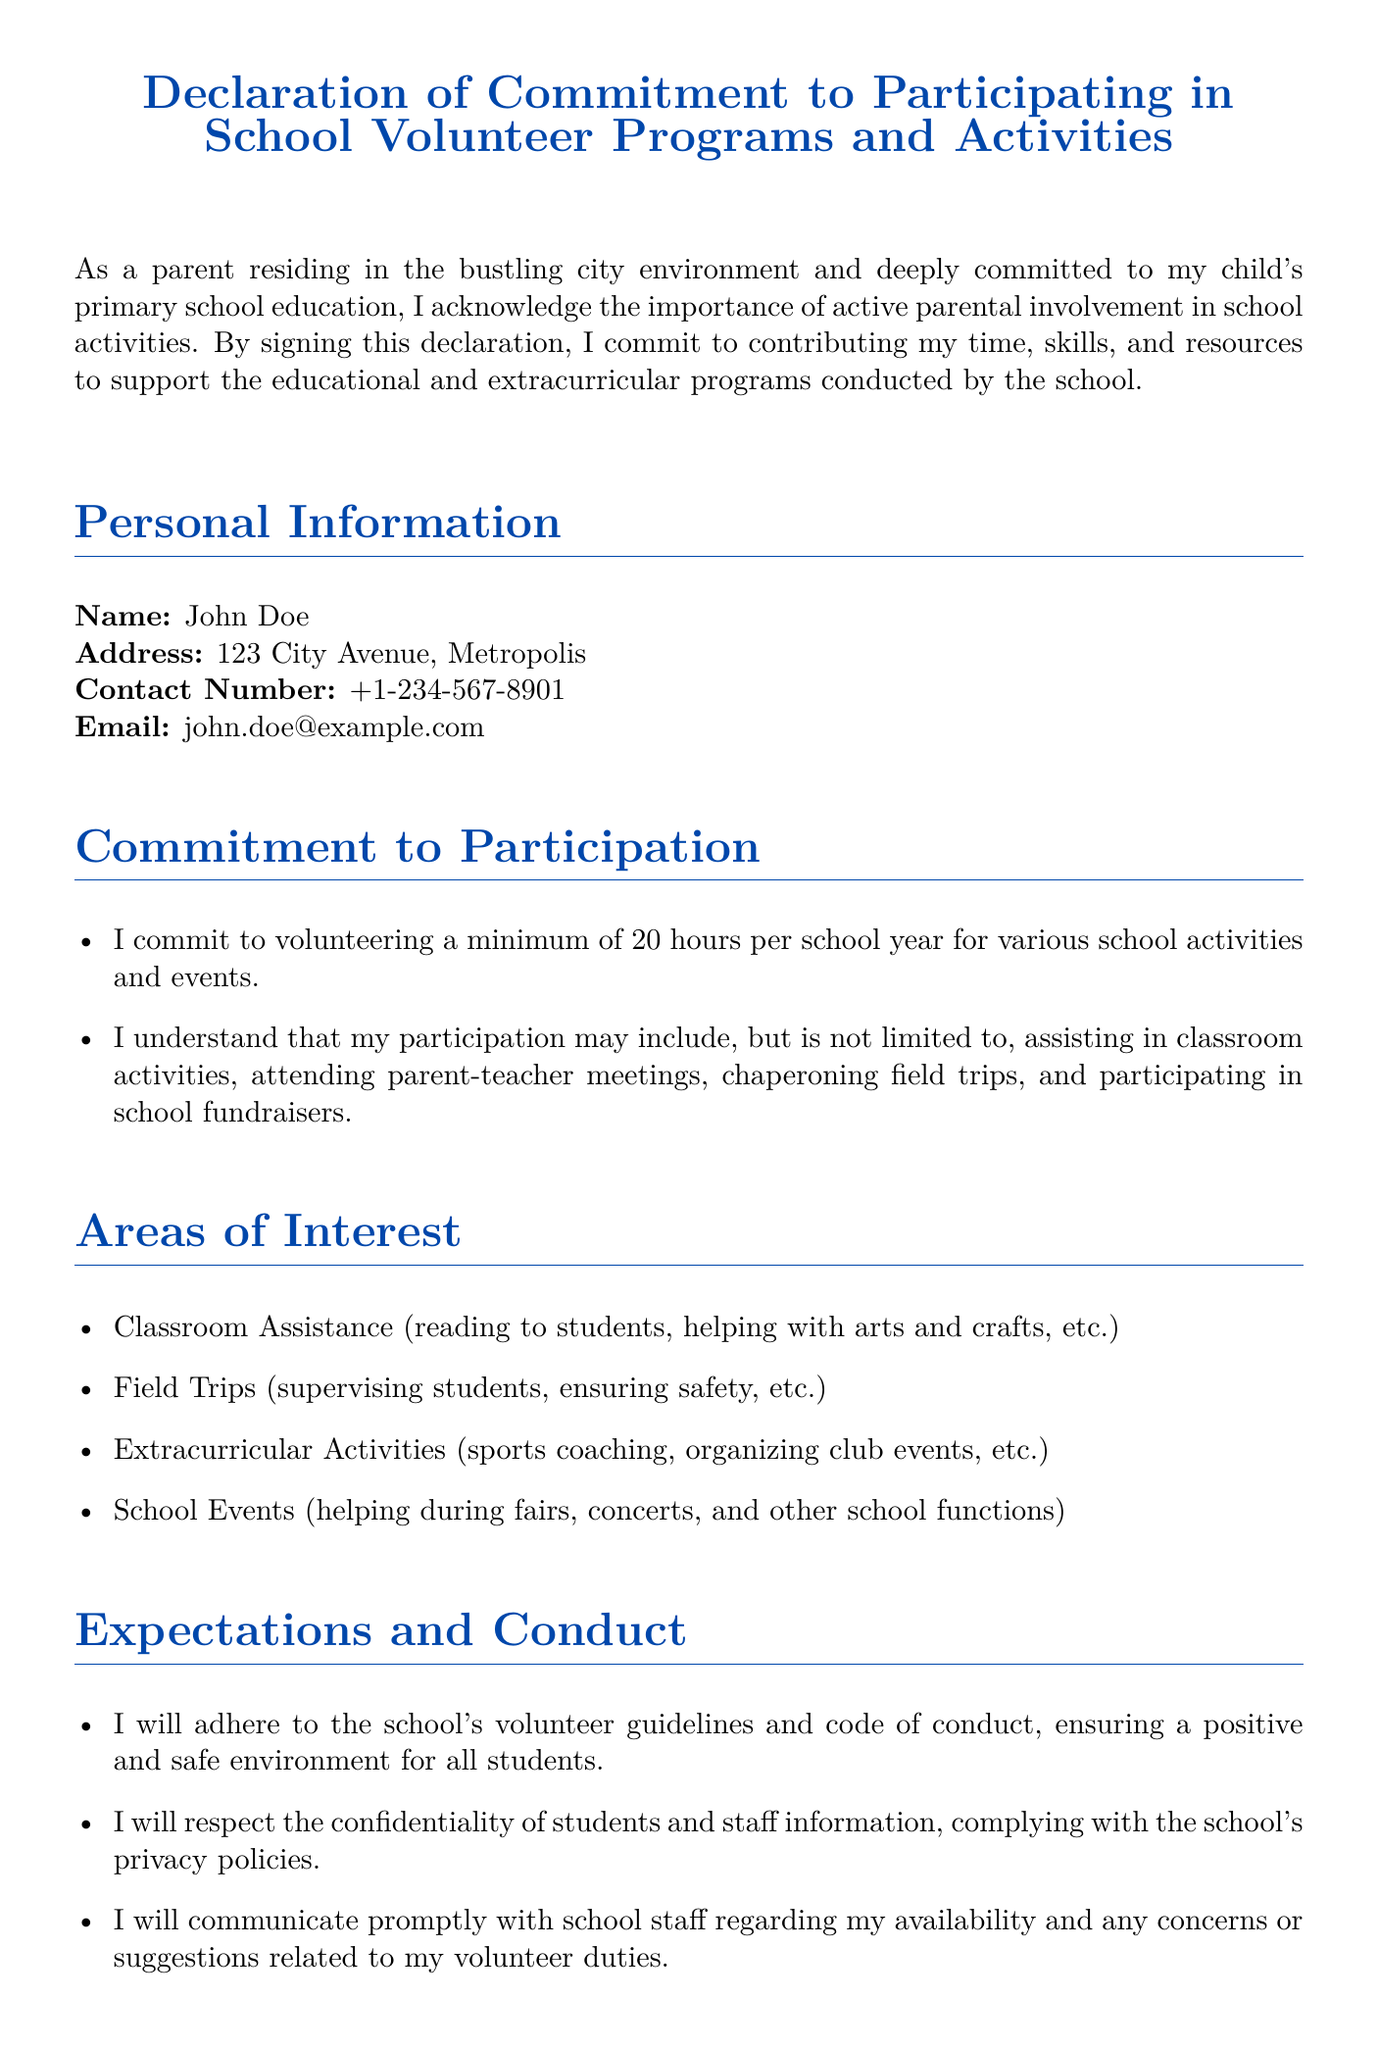What is the title of the document? The title of the document is stated at the top of the rendered document.
Answer: Declaration of Commitment to Participating in School Volunteer Programs and Activities Who is the signatory of the declaration? The signatory's name is mentioned in the personal information section of the document.
Answer: John Doe What is the minimum number of hours the signatory commits to volunteering? The commitment to volunteer hours is specified in the Commitment to Participation section.
Answer: 20 hours What is one area of interest for volunteering listed in the document? An example of an area of interest is provided in the Areas of Interest section.
Answer: Classroom Assistance What must the signatory adhere to during their volunteer participation? This is outlined in the Expectations and Conduct section of the document.
Answer: Volunteer guidelines What type of events might the signatory help with? This is mentioned in the Commitment to Participation section.
Answer: School fundraisers What must the signatory respect regarding student and staff information? This is stated in the Expectations and Conduct section.
Answer: Confidentiality How should the signatory communicate any concerns? The method of communication is described in the Expectations and Conduct section.
Answer: Promptly with school staff 